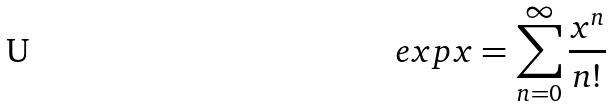<formula> <loc_0><loc_0><loc_500><loc_500>e x p x = \sum _ { n = 0 } ^ { \infty } \frac { x ^ { n } } { n ! }</formula> 